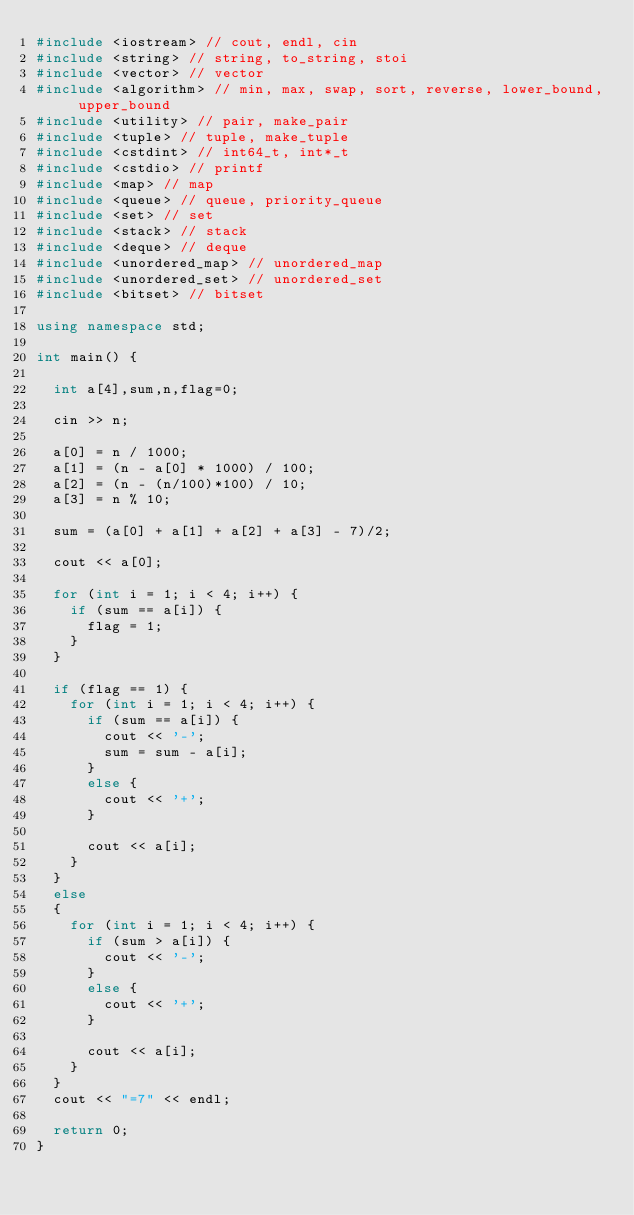<code> <loc_0><loc_0><loc_500><loc_500><_C++_>#include <iostream> // cout, endl, cin
#include <string> // string, to_string, stoi
#include <vector> // vector
#include <algorithm> // min, max, swap, sort, reverse, lower_bound, upper_bound
#include <utility> // pair, make_pair
#include <tuple> // tuple, make_tuple
#include <cstdint> // int64_t, int*_t
#include <cstdio> // printf
#include <map> // map
#include <queue> // queue, priority_queue
#include <set> // set
#include <stack> // stack
#include <deque> // deque
#include <unordered_map> // unordered_map
#include <unordered_set> // unordered_set
#include <bitset> // bitset

using namespace std;

int main() {

	int a[4],sum,n,flag=0;

	cin >> n;

	a[0] = n / 1000;
	a[1] = (n - a[0] * 1000) / 100;
	a[2] = (n - (n/100)*100) / 10;
	a[3] = n % 10;

	sum = (a[0] + a[1] + a[2] + a[3] - 7)/2;

	cout << a[0];

	for (int i = 1; i < 4; i++) {
		if (sum == a[i]) {
			flag = 1;
		}
	}

	if (flag == 1) {
		for (int i = 1; i < 4; i++) {
			if (sum == a[i]) {
				cout << '-';
				sum = sum - a[i];
			}
			else {
				cout << '+';
			}

			cout << a[i];
		}
	}
	else
	{
		for (int i = 1; i < 4; i++) {
			if (sum > a[i]) {
				cout << '-';
			}
			else {
				cout << '+';
			}

			cout << a[i];
		}
	}
	cout << "=7" << endl;

	return 0;
}
</code> 